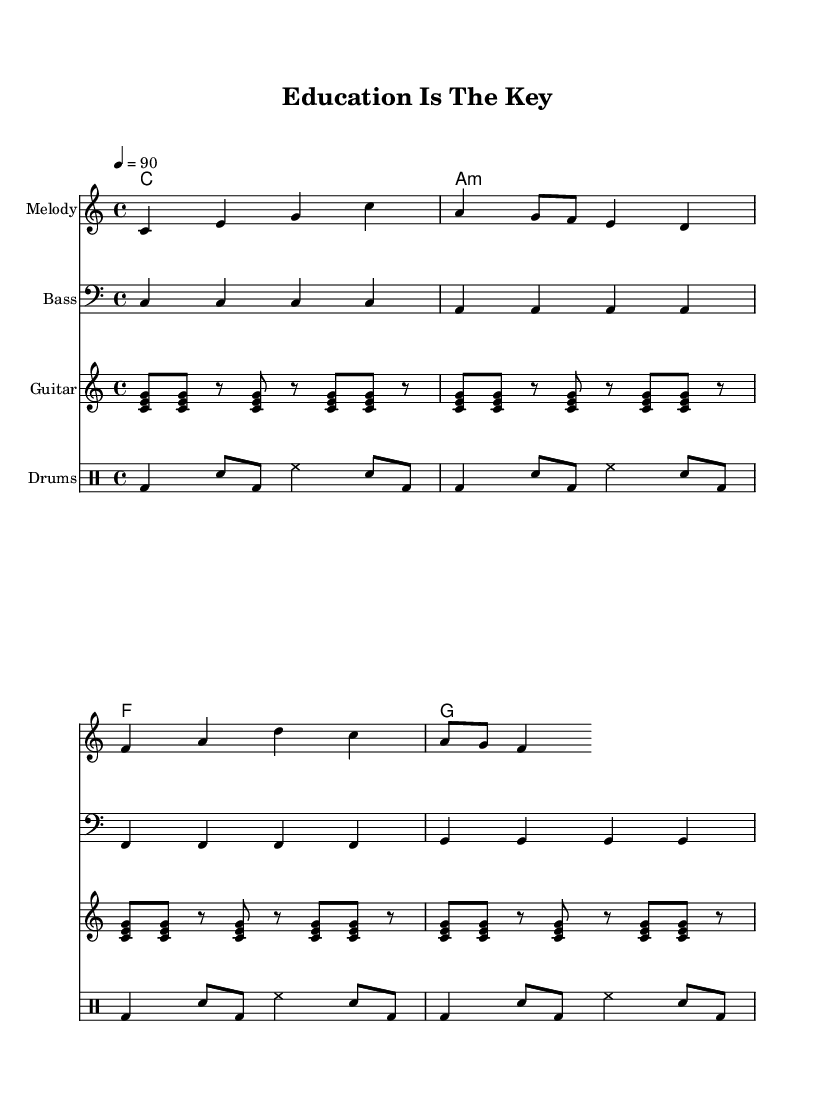What is the key signature of this music? The key signature is C major, which is indicated at the beginning of the sheet music. It has no sharps or flats.
Answer: C major What is the time signature of this music? The time signature is found in the beginning of the sheet music and is noted as 4/4, indicating four beats per measure with the quarter note getting one beat.
Answer: 4/4 What is the tempo marking for this piece? The tempo marking is provided in the header section and is indicated as 4 = 90, meaning there are 90 beats per minute for the quarter note.
Answer: 90 How many measures are in the melody? Counting the notes and rests in the melody line reveals that it consists of 4 measures, as indicated by the grouping of notes.
Answer: 4 What role does the bassline play in this reggae tune? The bassline, which is a consistent pattern of quarter notes, grounds the harmony and supports the rhythm, typical in reggae to provide a steady foundation.
Answer: Grounding What is the main theme of the lyrics in this piece? The lyrics promote education and emphasize hard work as key to achieving one's dreams, which aligns with the educational message of the music.
Answer: Education 